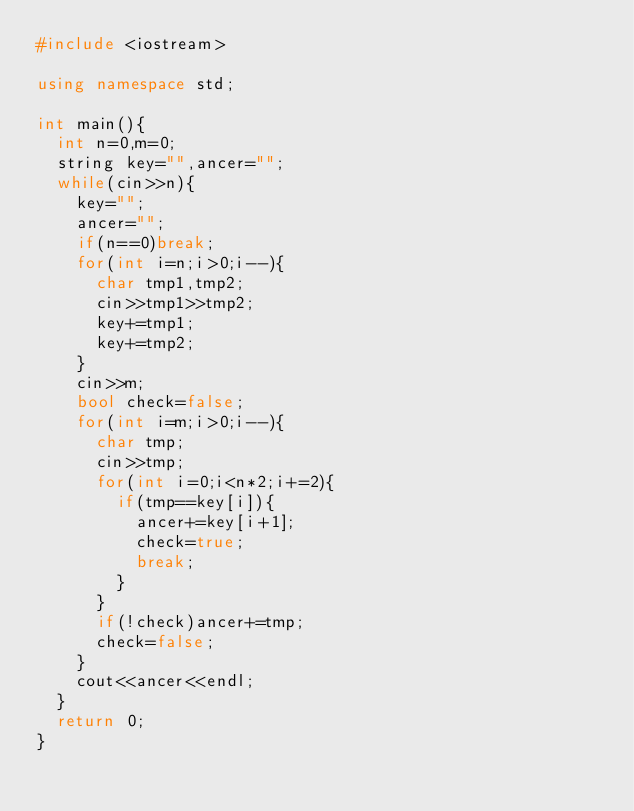<code> <loc_0><loc_0><loc_500><loc_500><_C++_>#include <iostream>

using namespace std;

int main(){
	int n=0,m=0;
	string key="",ancer="";
	while(cin>>n){
		key="";
		ancer="";
		if(n==0)break;
		for(int i=n;i>0;i--){
			char tmp1,tmp2;
			cin>>tmp1>>tmp2;
			key+=tmp1;
			key+=tmp2;
		}
		cin>>m;
		bool check=false;
		for(int i=m;i>0;i--){
			char tmp;
			cin>>tmp;
			for(int i=0;i<n*2;i+=2){
				if(tmp==key[i]){
					ancer+=key[i+1];
					check=true;
					break;
				}
			}
			if(!check)ancer+=tmp;
			check=false;
		}
		cout<<ancer<<endl;
	}
	return 0;
}
</code> 